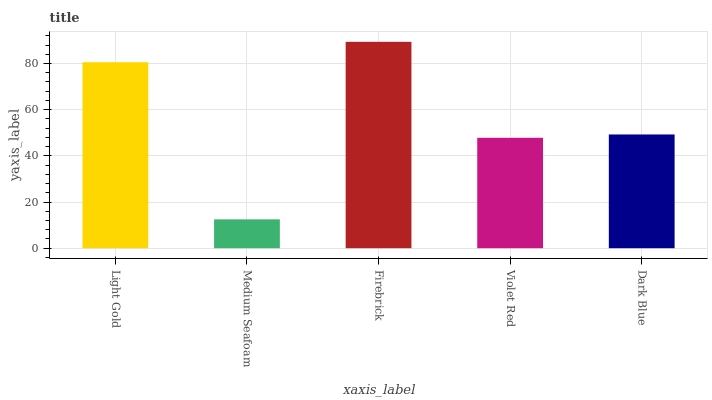Is Medium Seafoam the minimum?
Answer yes or no. Yes. Is Firebrick the maximum?
Answer yes or no. Yes. Is Firebrick the minimum?
Answer yes or no. No. Is Medium Seafoam the maximum?
Answer yes or no. No. Is Firebrick greater than Medium Seafoam?
Answer yes or no. Yes. Is Medium Seafoam less than Firebrick?
Answer yes or no. Yes. Is Medium Seafoam greater than Firebrick?
Answer yes or no. No. Is Firebrick less than Medium Seafoam?
Answer yes or no. No. Is Dark Blue the high median?
Answer yes or no. Yes. Is Dark Blue the low median?
Answer yes or no. Yes. Is Light Gold the high median?
Answer yes or no. No. Is Firebrick the low median?
Answer yes or no. No. 